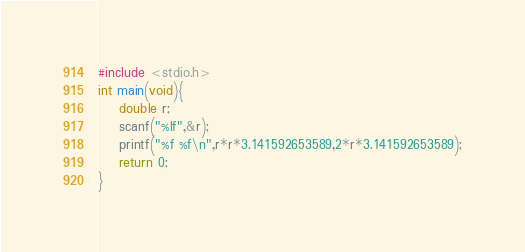Convert code to text. <code><loc_0><loc_0><loc_500><loc_500><_C_>#include <stdio.h>
int main(void){
    double r;
    scanf("%lf",&r);
    printf("%f %f\n",r*r*3.141592653589,2*r*3.141592653589);
    return 0;
}
</code> 